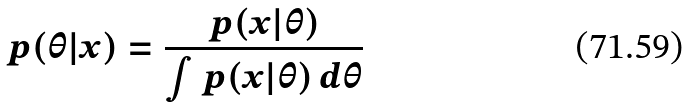Convert formula to latex. <formula><loc_0><loc_0><loc_500><loc_500>p ( \theta | x ) = \frac { p ( x | \theta ) } { \int p ( x | \theta ) \, d \theta }</formula> 